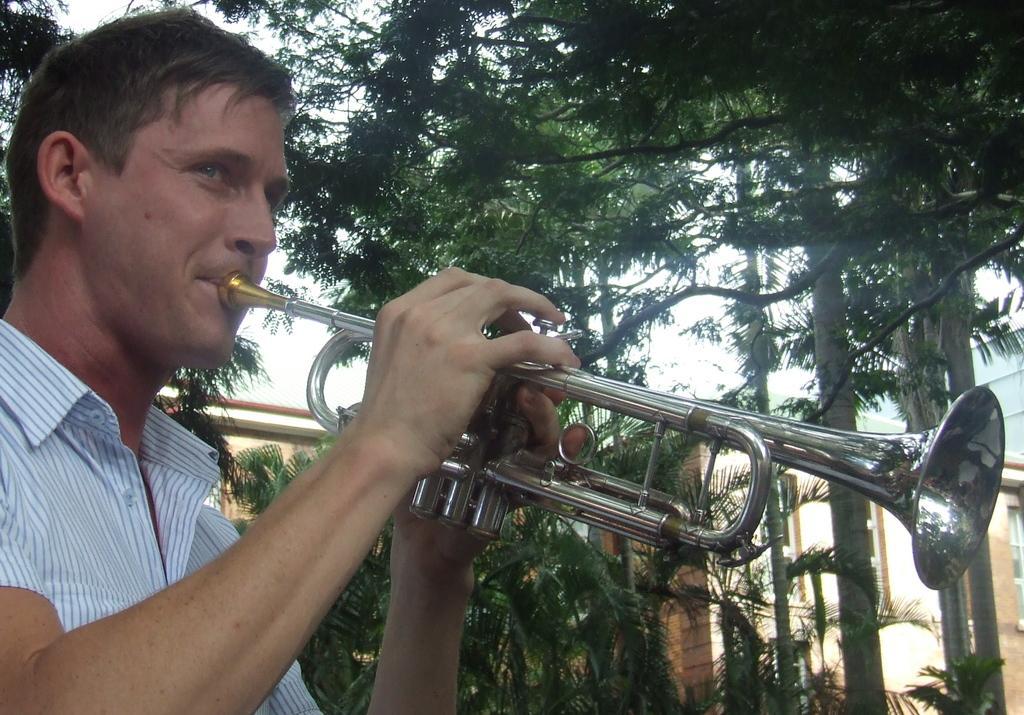Can you describe this image briefly? In the picture we can see a man standing and playing a musical instrument and in the background, we can see plants, trees, building walls and sky. 